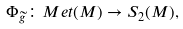<formula> <loc_0><loc_0><loc_500><loc_500>\Phi _ { \widetilde { g } } \colon M e t ( M ) \rightarrow S _ { 2 } ( M ) ,</formula> 